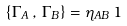<formula> <loc_0><loc_0><loc_500><loc_500>\left \{ \Gamma _ { A } \, , \, \Gamma _ { B } \right \} = \eta _ { A B } \, { 1 }</formula> 